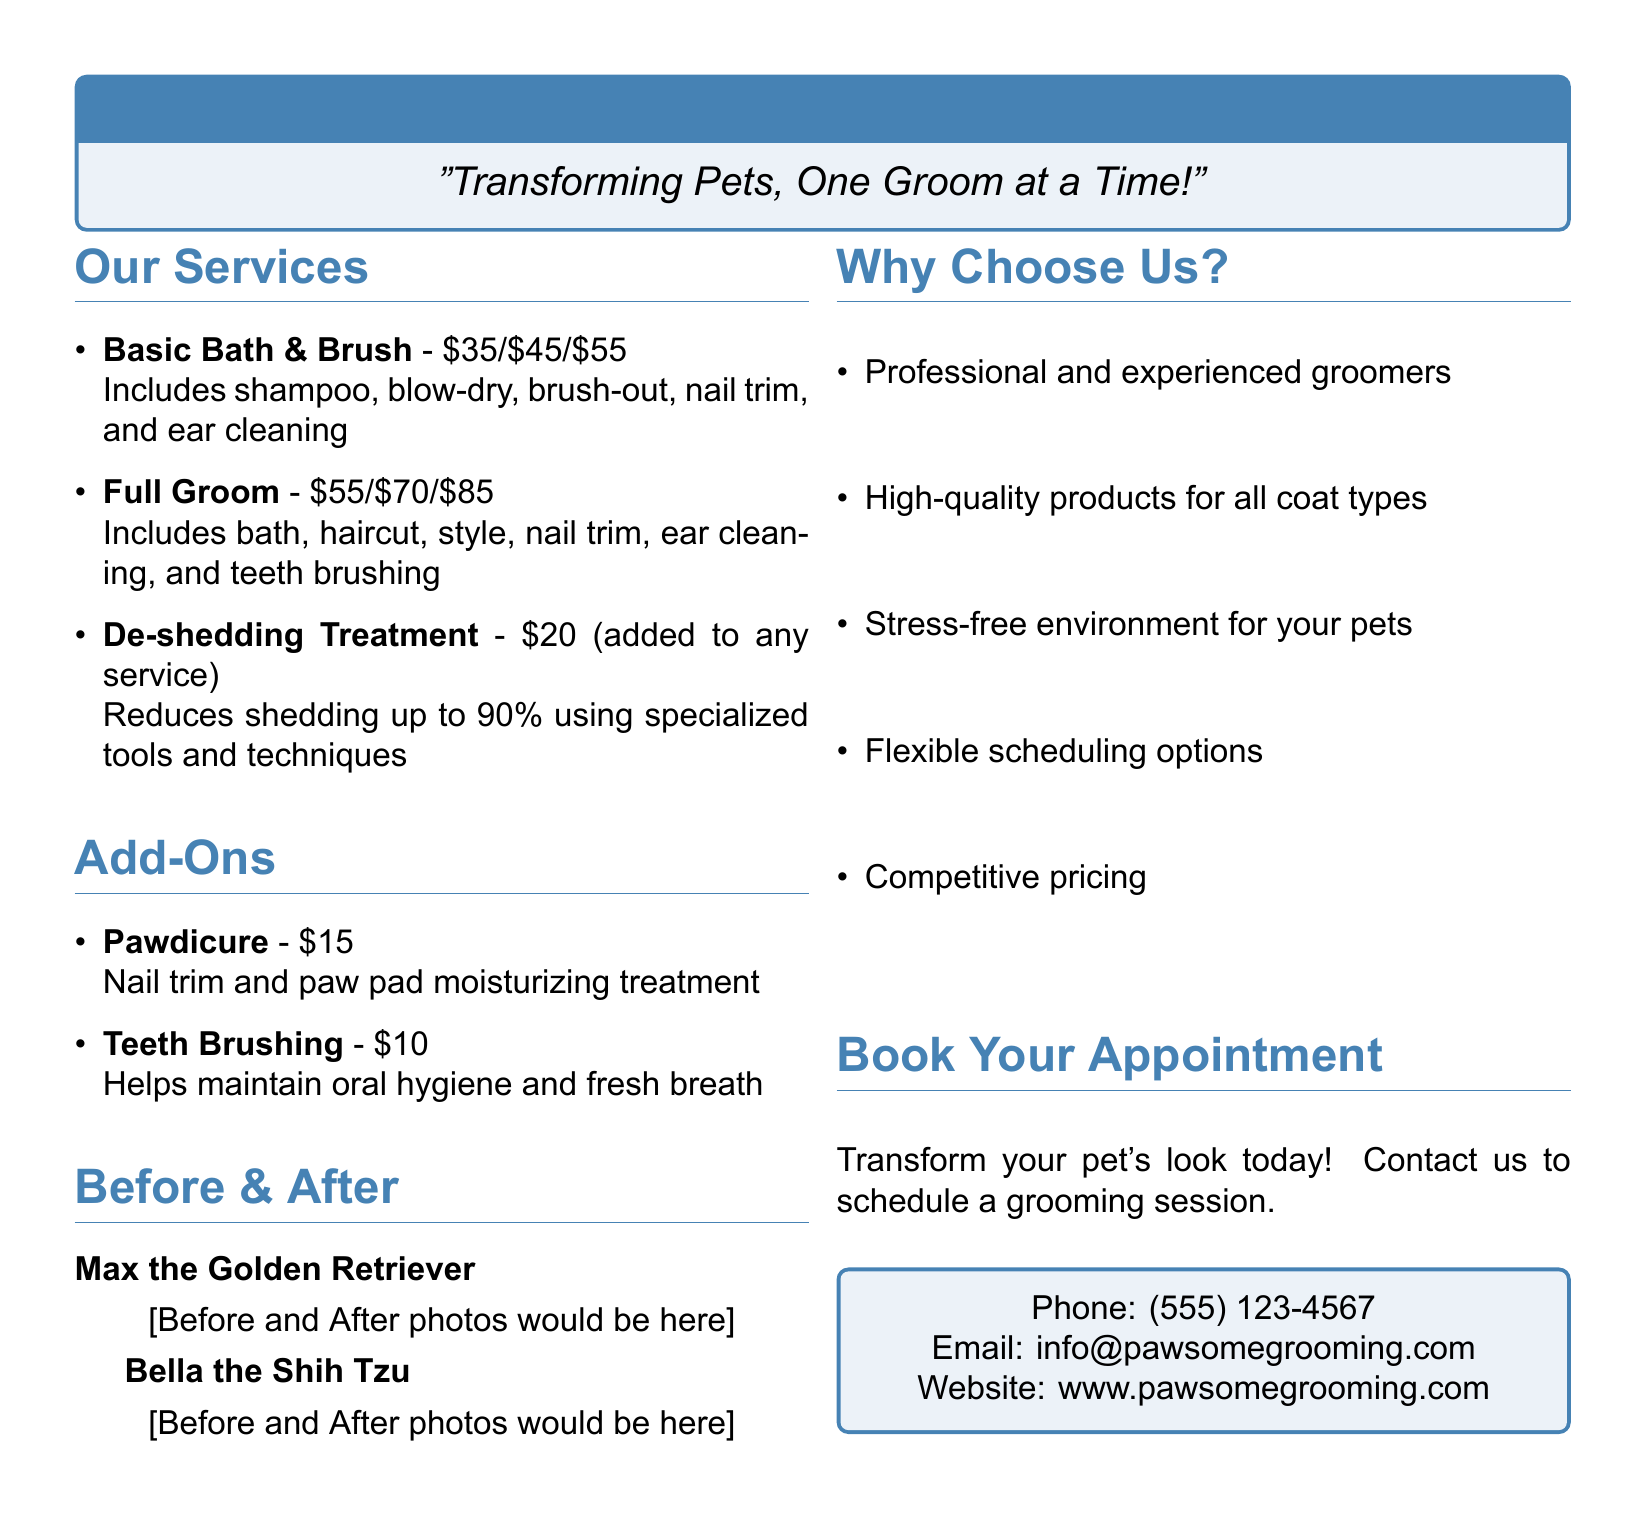What is the price range for a Full Groom service? The price range for a Full Groom service is listed as $55, $70, and $85.
Answer: $55/$70/$85 What does the Basic Bath & Brush service include? The Basic Bath & Brush service includes shampoo, blow-dry, brush-out, nail trim, and ear cleaning.
Answer: Shampoo, blow-dry, brush-out, nail trim, and ear cleaning How much does the De-shedding Treatment cost? The De-shedding Treatment costs $20 when added to any service.
Answer: $20 What is the price of a Pawdicure add-on? The price of a Pawdicure add-on is $15.
Answer: $15 Who is featured in the Before & After photos? The Before & After photos feature Max the Golden Retriever and Bella the Shih Tzu.
Answer: Max the Golden Retriever and Bella the Shih Tzu What are two reasons to choose this grooming salon? Two reasons to choose this grooming salon include professional and experienced groomers, and a stress-free environment for your pets.
Answer: Professional groomers and stress-free environment What is the phone number for booking an appointment? The phone number for booking an appointment is provided as (555) 123-4567.
Answer: (555) 123-4567 How many sections are in the document? The document contains five main sections: Our Services, Add-Ons, Before & After, Why Choose Us?, and Book Your Appointment.
Answer: Five sections 